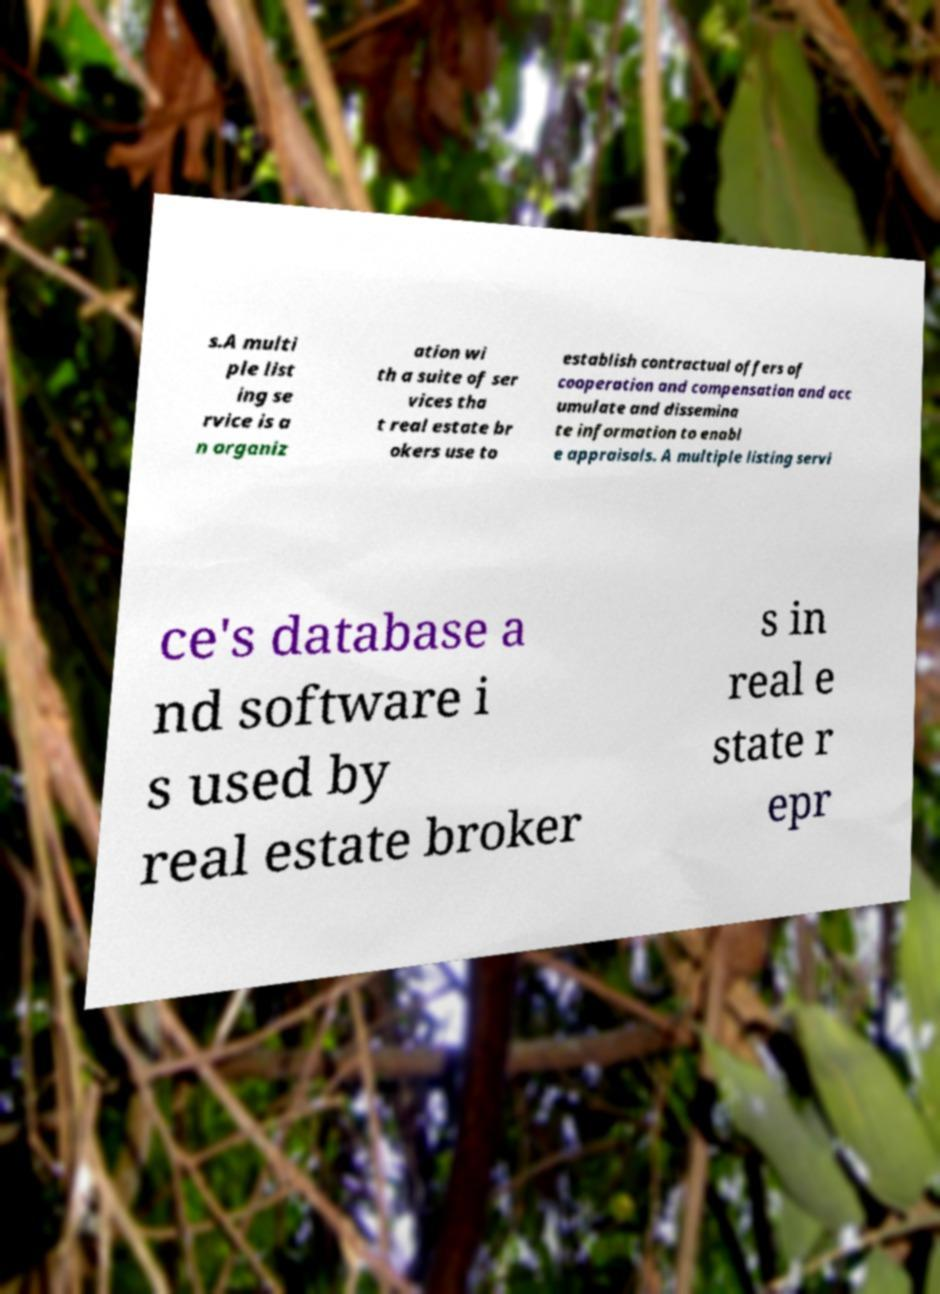For documentation purposes, I need the text within this image transcribed. Could you provide that? s.A multi ple list ing se rvice is a n organiz ation wi th a suite of ser vices tha t real estate br okers use to establish contractual offers of cooperation and compensation and acc umulate and dissemina te information to enabl e appraisals. A multiple listing servi ce's database a nd software i s used by real estate broker s in real e state r epr 